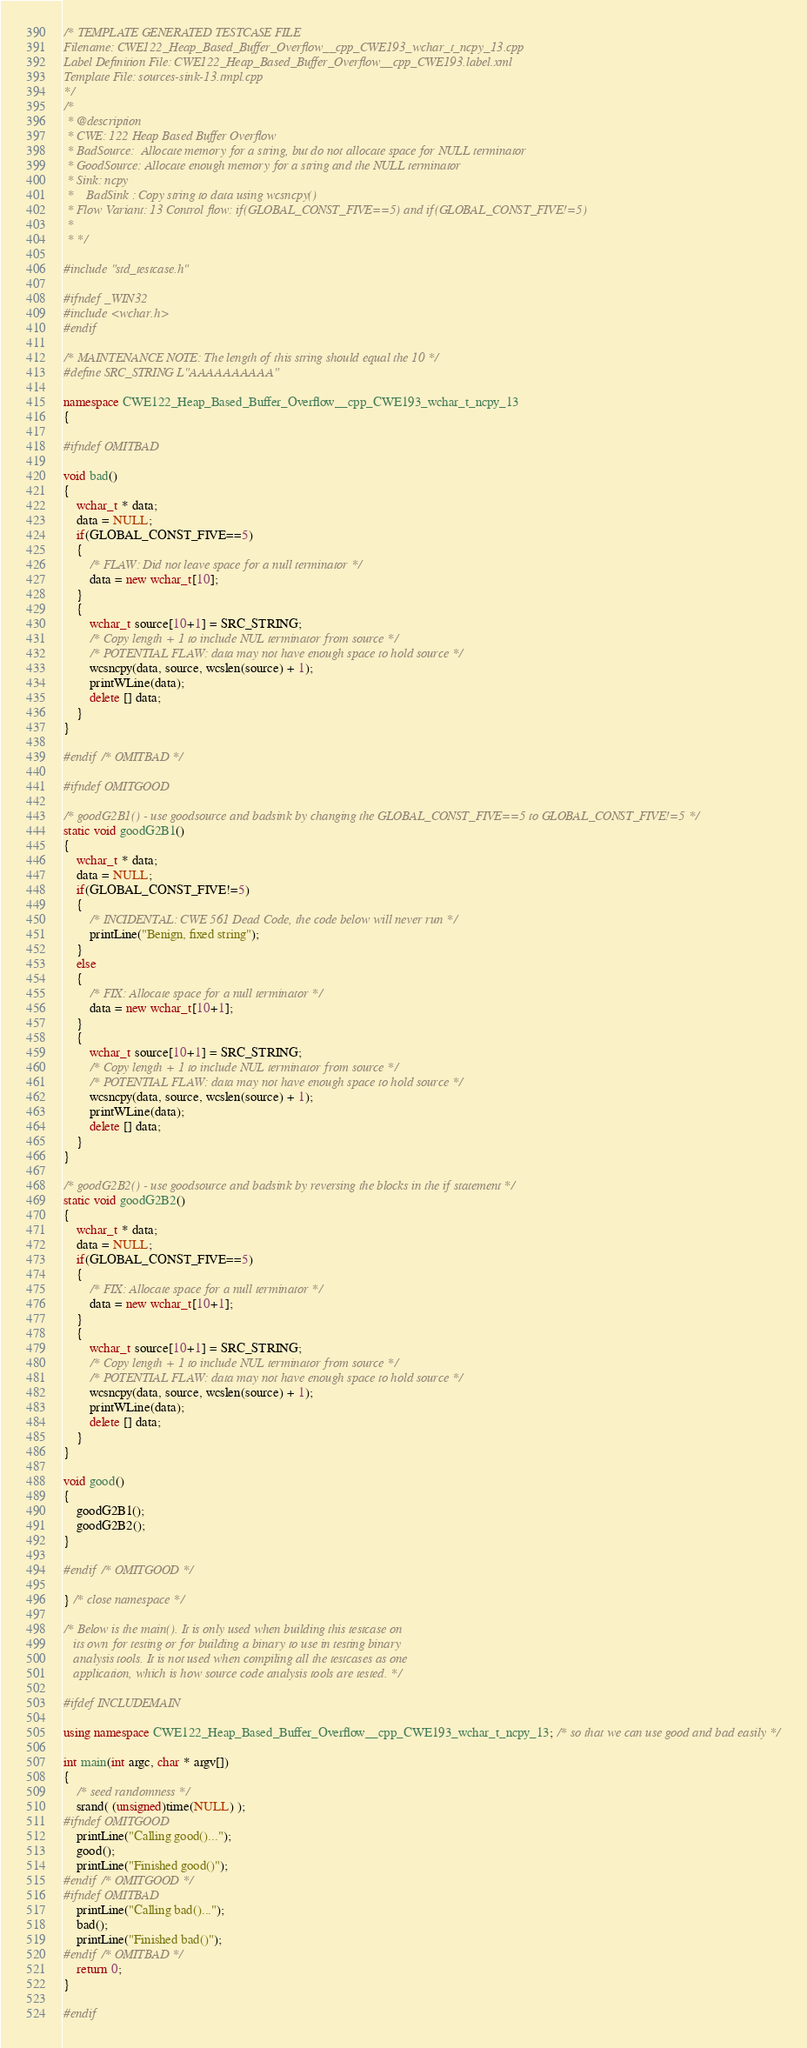<code> <loc_0><loc_0><loc_500><loc_500><_C++_>/* TEMPLATE GENERATED TESTCASE FILE
Filename: CWE122_Heap_Based_Buffer_Overflow__cpp_CWE193_wchar_t_ncpy_13.cpp
Label Definition File: CWE122_Heap_Based_Buffer_Overflow__cpp_CWE193.label.xml
Template File: sources-sink-13.tmpl.cpp
*/
/*
 * @description
 * CWE: 122 Heap Based Buffer Overflow
 * BadSource:  Allocate memory for a string, but do not allocate space for NULL terminator
 * GoodSource: Allocate enough memory for a string and the NULL terminator
 * Sink: ncpy
 *    BadSink : Copy string to data using wcsncpy()
 * Flow Variant: 13 Control flow: if(GLOBAL_CONST_FIVE==5) and if(GLOBAL_CONST_FIVE!=5)
 *
 * */

#include "std_testcase.h"

#ifndef _WIN32
#include <wchar.h>
#endif

/* MAINTENANCE NOTE: The length of this string should equal the 10 */
#define SRC_STRING L"AAAAAAAAAA"

namespace CWE122_Heap_Based_Buffer_Overflow__cpp_CWE193_wchar_t_ncpy_13
{

#ifndef OMITBAD

void bad()
{
    wchar_t * data;
    data = NULL;
    if(GLOBAL_CONST_FIVE==5)
    {
        /* FLAW: Did not leave space for a null terminator */
        data = new wchar_t[10];
    }
    {
        wchar_t source[10+1] = SRC_STRING;
        /* Copy length + 1 to include NUL terminator from source */
        /* POTENTIAL FLAW: data may not have enough space to hold source */
        wcsncpy(data, source, wcslen(source) + 1);
        printWLine(data);
        delete [] data;
    }
}

#endif /* OMITBAD */

#ifndef OMITGOOD

/* goodG2B1() - use goodsource and badsink by changing the GLOBAL_CONST_FIVE==5 to GLOBAL_CONST_FIVE!=5 */
static void goodG2B1()
{
    wchar_t * data;
    data = NULL;
    if(GLOBAL_CONST_FIVE!=5)
    {
        /* INCIDENTAL: CWE 561 Dead Code, the code below will never run */
        printLine("Benign, fixed string");
    }
    else
    {
        /* FIX: Allocate space for a null terminator */
        data = new wchar_t[10+1];
    }
    {
        wchar_t source[10+1] = SRC_STRING;
        /* Copy length + 1 to include NUL terminator from source */
        /* POTENTIAL FLAW: data may not have enough space to hold source */
        wcsncpy(data, source, wcslen(source) + 1);
        printWLine(data);
        delete [] data;
    }
}

/* goodG2B2() - use goodsource and badsink by reversing the blocks in the if statement */
static void goodG2B2()
{
    wchar_t * data;
    data = NULL;
    if(GLOBAL_CONST_FIVE==5)
    {
        /* FIX: Allocate space for a null terminator */
        data = new wchar_t[10+1];
    }
    {
        wchar_t source[10+1] = SRC_STRING;
        /* Copy length + 1 to include NUL terminator from source */
        /* POTENTIAL FLAW: data may not have enough space to hold source */
        wcsncpy(data, source, wcslen(source) + 1);
        printWLine(data);
        delete [] data;
    }
}

void good()
{
    goodG2B1();
    goodG2B2();
}

#endif /* OMITGOOD */

} /* close namespace */

/* Below is the main(). It is only used when building this testcase on
   its own for testing or for building a binary to use in testing binary
   analysis tools. It is not used when compiling all the testcases as one
   application, which is how source code analysis tools are tested. */

#ifdef INCLUDEMAIN

using namespace CWE122_Heap_Based_Buffer_Overflow__cpp_CWE193_wchar_t_ncpy_13; /* so that we can use good and bad easily */

int main(int argc, char * argv[])
{
    /* seed randomness */
    srand( (unsigned)time(NULL) );
#ifndef OMITGOOD
    printLine("Calling good()...");
    good();
    printLine("Finished good()");
#endif /* OMITGOOD */
#ifndef OMITBAD
    printLine("Calling bad()...");
    bad();
    printLine("Finished bad()");
#endif /* OMITBAD */
    return 0;
}

#endif
</code> 